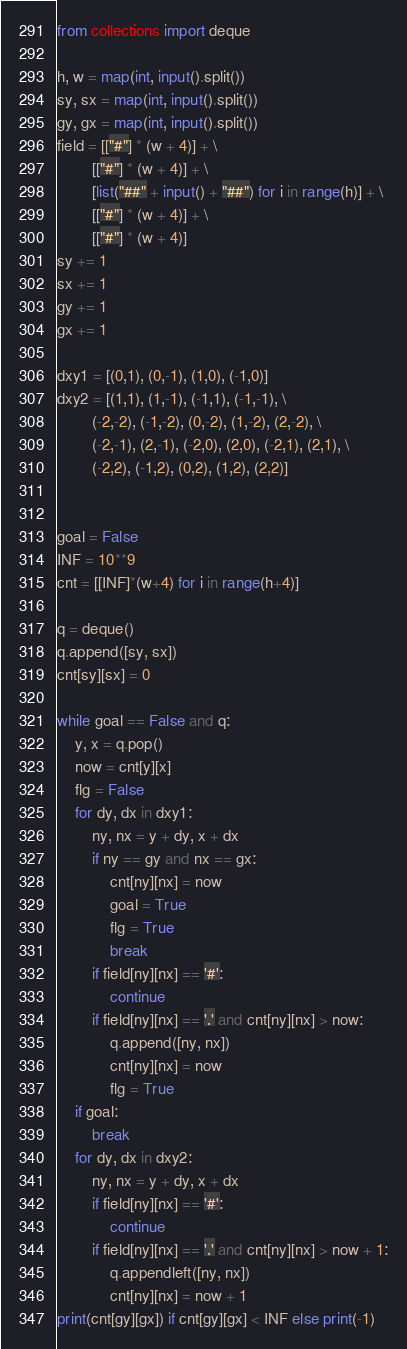Convert code to text. <code><loc_0><loc_0><loc_500><loc_500><_Python_>from collections import deque

h, w = map(int, input().split())
sy, sx = map(int, input().split())
gy, gx = map(int, input().split())
field = [["#"] * (w + 4)] + \
        [["#"] * (w + 4)] + \
        [list("##" + input() + "##") for i in range(h)] + \
        [["#"] * (w + 4)] + \
        [["#"] * (w + 4)]
sy += 1
sx += 1
gy += 1
gx += 1          
          
dxy1 = [(0,1), (0,-1), (1,0), (-1,0)]
dxy2 = [(1,1), (1,-1), (-1,1), (-1,-1), \
        (-2,-2), (-1,-2), (0,-2), (1,-2), (2,-2), \
        (-2,-1), (2,-1), (-2,0), (2,0), (-2,1), (2,1), \
        (-2,2), (-1,2), (0,2), (1,2), (2,2)]


goal = False
INF = 10**9
cnt = [[INF]*(w+4) for i in range(h+4)]

q = deque()
q.append([sy, sx])
cnt[sy][sx] = 0

while goal == False and q:
    y, x = q.pop()
    now = cnt[y][x]
    flg = False
    for dy, dx in dxy1:
        ny, nx = y + dy, x + dx
        if ny == gy and nx == gx:
            cnt[ny][nx] = now
            goal = True
            flg = True
            break
        if field[ny][nx] == '#':
            continue
        if field[ny][nx] == '.' and cnt[ny][nx] > now:
            q.append([ny, nx])
            cnt[ny][nx] = now
            flg = True
    if goal:
        break
    for dy, dx in dxy2:
        ny, nx = y + dy, x + dx
        if field[ny][nx] == '#':
            continue
        if field[ny][nx] == '.' and cnt[ny][nx] > now + 1:
            q.appendleft([ny, nx])
            cnt[ny][nx] = now + 1
print(cnt[gy][gx]) if cnt[gy][gx] < INF else print(-1)</code> 